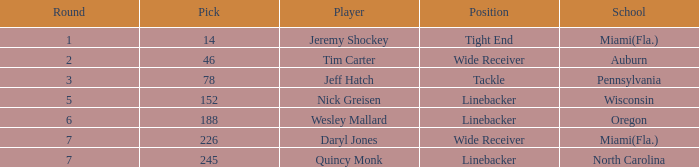From which institution did the linebacker with a pick under 245 and selected in the 6th round graduate? Oregon. 